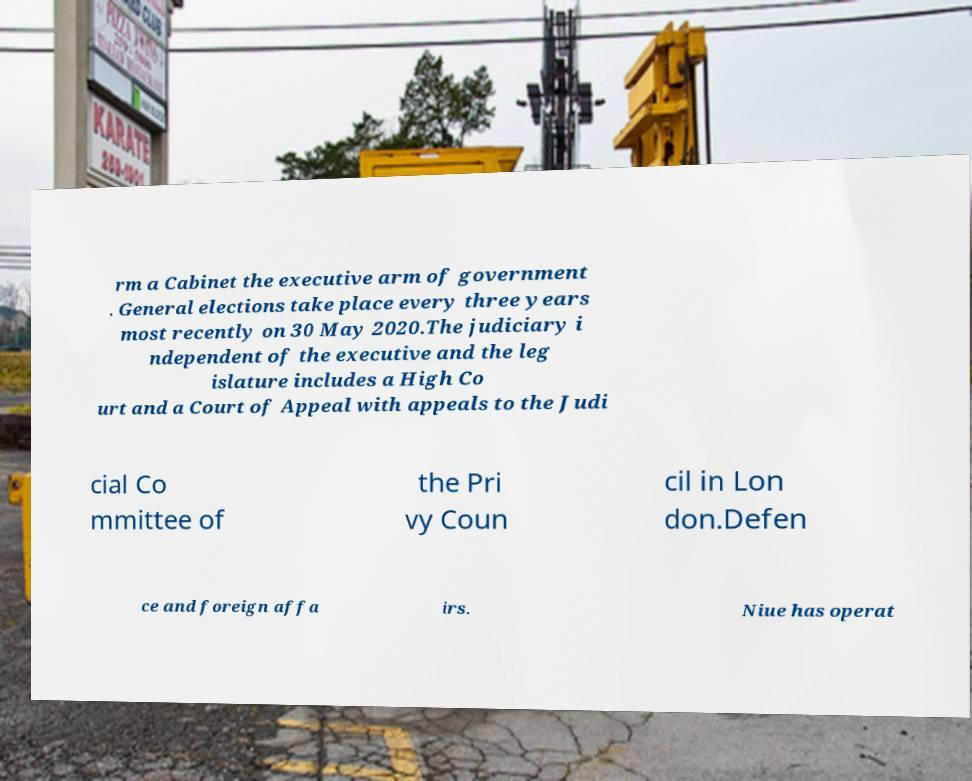Please identify and transcribe the text found in this image. rm a Cabinet the executive arm of government . General elections take place every three years most recently on 30 May 2020.The judiciary i ndependent of the executive and the leg islature includes a High Co urt and a Court of Appeal with appeals to the Judi cial Co mmittee of the Pri vy Coun cil in Lon don.Defen ce and foreign affa irs. Niue has operat 